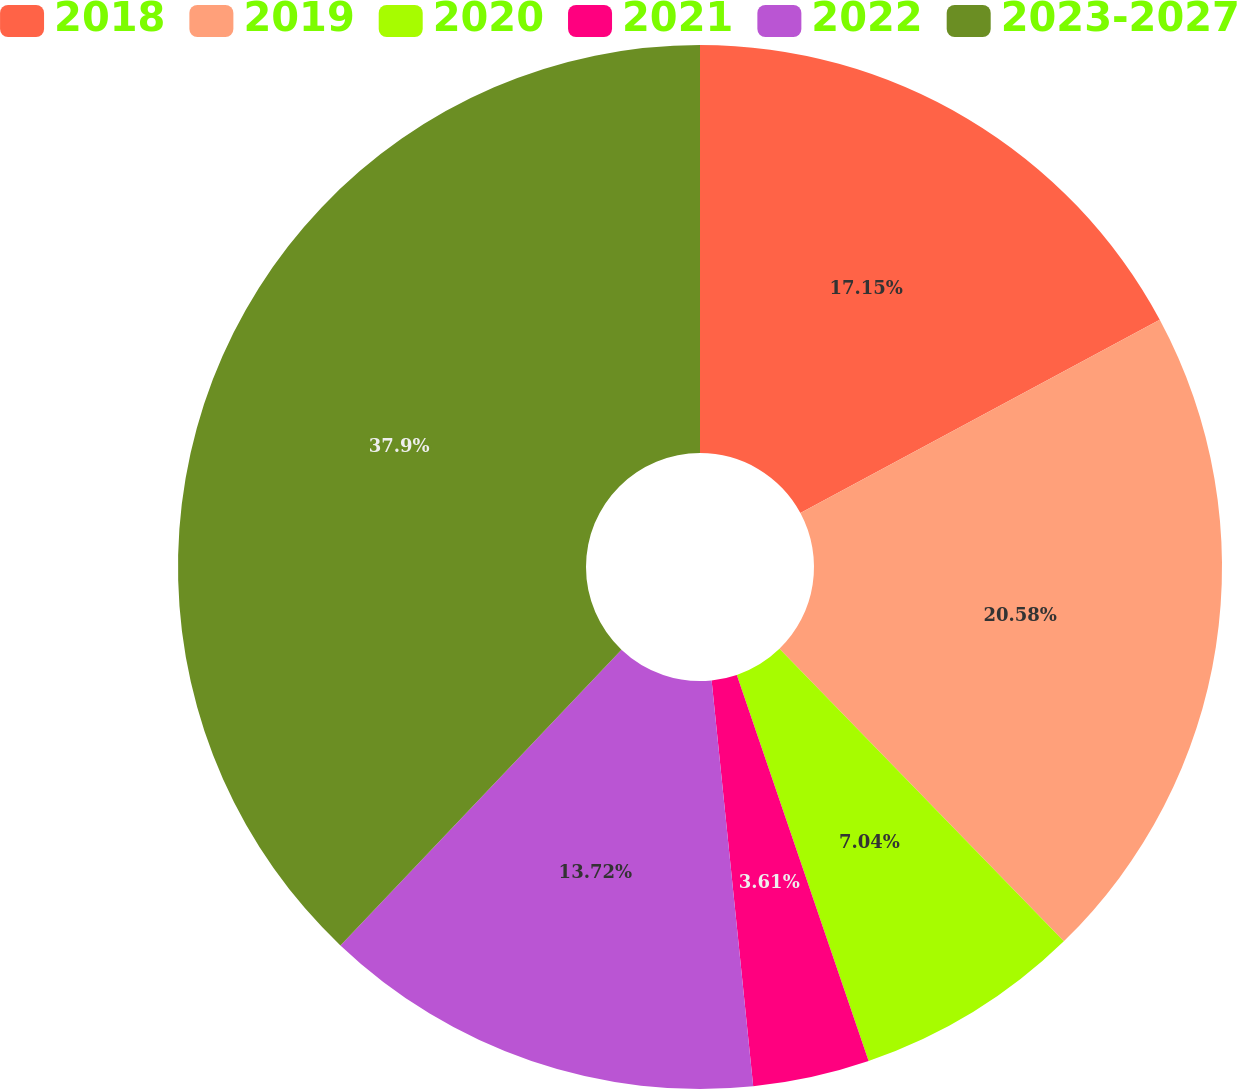Convert chart to OTSL. <chart><loc_0><loc_0><loc_500><loc_500><pie_chart><fcel>2018<fcel>2019<fcel>2020<fcel>2021<fcel>2022<fcel>2023-2027<nl><fcel>17.15%<fcel>20.58%<fcel>7.04%<fcel>3.61%<fcel>13.72%<fcel>37.91%<nl></chart> 